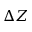Convert formula to latex. <formula><loc_0><loc_0><loc_500><loc_500>\Delta Z</formula> 